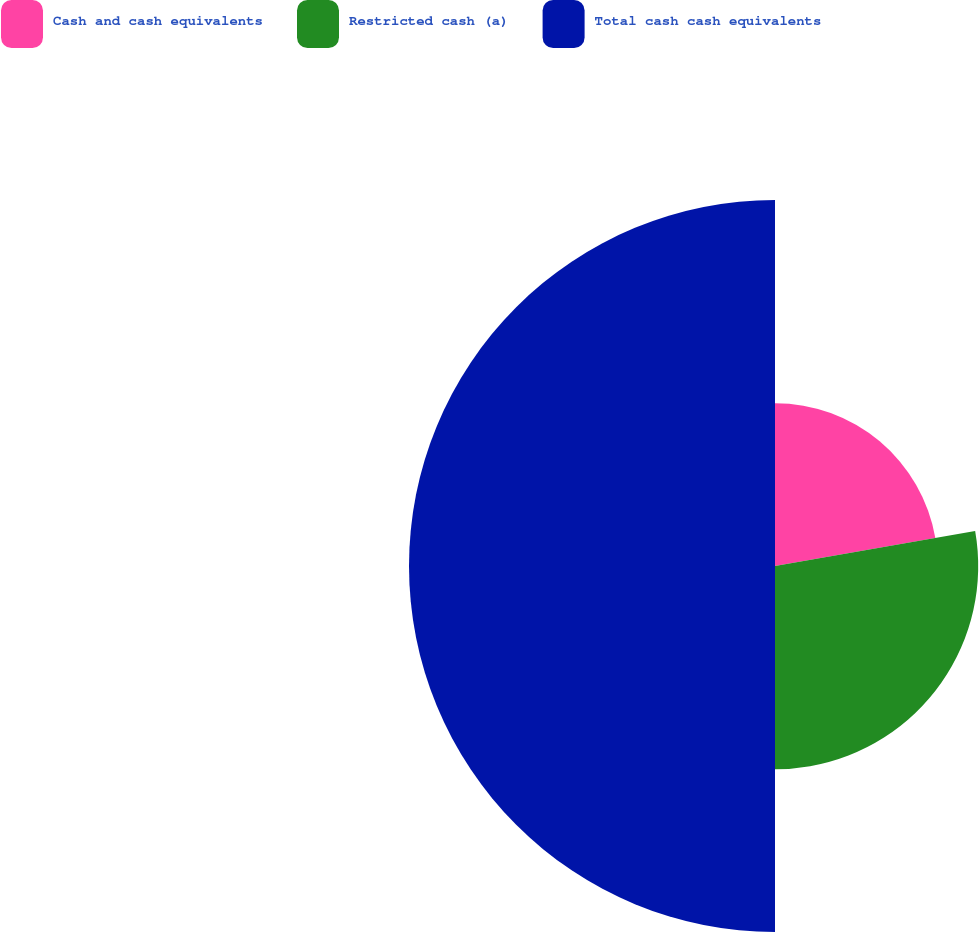Convert chart to OTSL. <chart><loc_0><loc_0><loc_500><loc_500><pie_chart><fcel>Cash and cash equivalents<fcel>Restricted cash (a)<fcel>Total cash cash equivalents<nl><fcel>22.24%<fcel>27.76%<fcel>50.0%<nl></chart> 